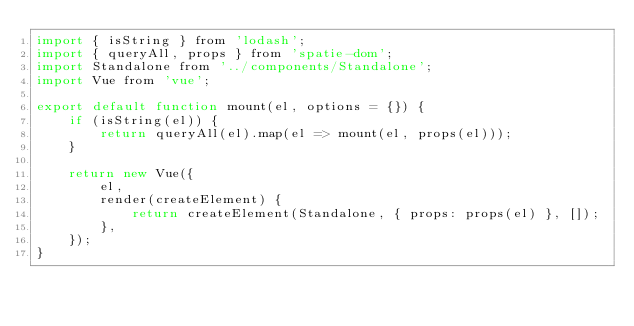<code> <loc_0><loc_0><loc_500><loc_500><_JavaScript_>import { isString } from 'lodash';
import { queryAll, props } from 'spatie-dom';
import Standalone from '../components/Standalone';
import Vue from 'vue';

export default function mount(el, options = {}) {
    if (isString(el)) {
        return queryAll(el).map(el => mount(el, props(el)));
    }
    
    return new Vue({
        el,
        render(createElement) {
            return createElement(Standalone, { props: props(el) }, []);
        },
    });
}</code> 